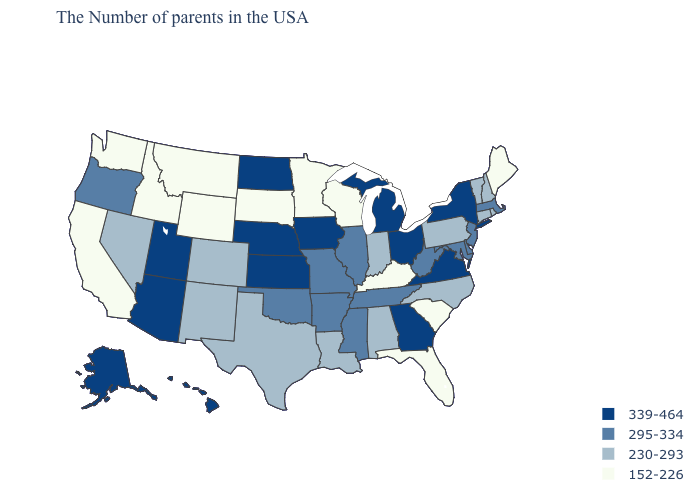Does North Dakota have the lowest value in the MidWest?
Give a very brief answer. No. What is the value of Alabama?
Write a very short answer. 230-293. Among the states that border Georgia , which have the highest value?
Concise answer only. Tennessee. Does the map have missing data?
Answer briefly. No. Does North Dakota have the highest value in the USA?
Short answer required. Yes. Among the states that border West Virginia , does Maryland have the highest value?
Short answer required. No. Name the states that have a value in the range 230-293?
Short answer required. Rhode Island, New Hampshire, Vermont, Connecticut, Pennsylvania, North Carolina, Indiana, Alabama, Louisiana, Texas, Colorado, New Mexico, Nevada. What is the value of Alabama?
Write a very short answer. 230-293. What is the highest value in states that border Kansas?
Write a very short answer. 339-464. What is the lowest value in the MidWest?
Answer briefly. 152-226. Name the states that have a value in the range 339-464?
Give a very brief answer. New York, Virginia, Ohio, Georgia, Michigan, Iowa, Kansas, Nebraska, North Dakota, Utah, Arizona, Alaska, Hawaii. What is the lowest value in the USA?
Answer briefly. 152-226. Name the states that have a value in the range 339-464?
Be succinct. New York, Virginia, Ohio, Georgia, Michigan, Iowa, Kansas, Nebraska, North Dakota, Utah, Arizona, Alaska, Hawaii. Does New York have the highest value in the Northeast?
Give a very brief answer. Yes. 